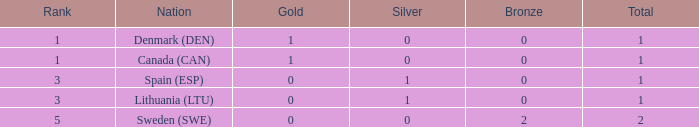When the total number of medals is greater than 1 and there is at least one gold, how many bronze medals were obtained? None. 